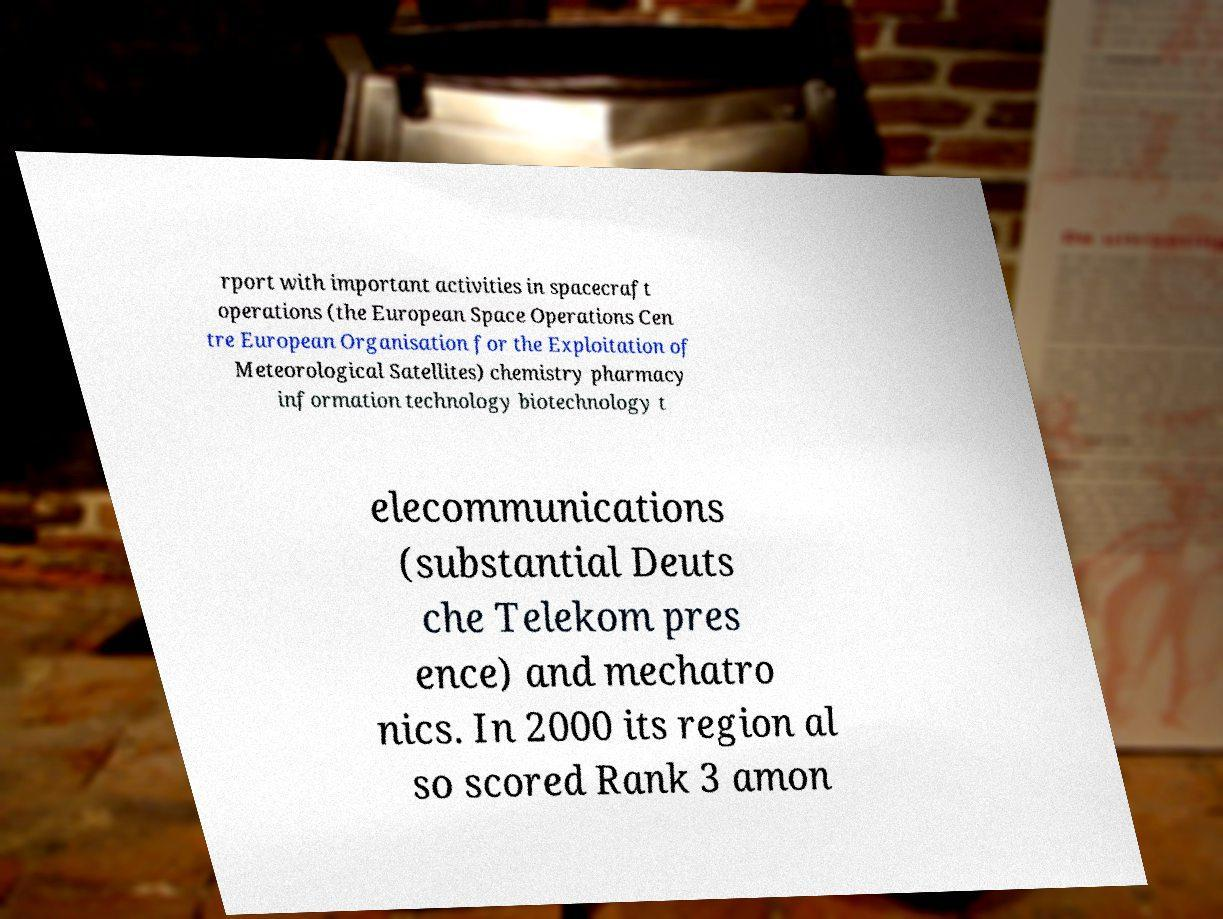Please identify and transcribe the text found in this image. rport with important activities in spacecraft operations (the European Space Operations Cen tre European Organisation for the Exploitation of Meteorological Satellites) chemistry pharmacy information technology biotechnology t elecommunications (substantial Deuts che Telekom pres ence) and mechatro nics. In 2000 its region al so scored Rank 3 amon 